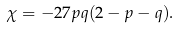Convert formula to latex. <formula><loc_0><loc_0><loc_500><loc_500>\chi = - 2 7 p q ( 2 - p - q ) .</formula> 